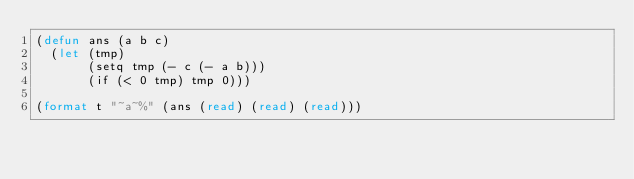<code> <loc_0><loc_0><loc_500><loc_500><_Lisp_>(defun ans (a b c)
  (let (tmp)
       (setq tmp (- c (- a b)))
       (if (< 0 tmp) tmp 0)))

(format t "~a~%" (ans (read) (read) (read)))</code> 